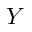Convert formula to latex. <formula><loc_0><loc_0><loc_500><loc_500>Y</formula> 